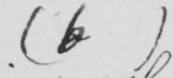Please transcribe the handwritten text in this image. ( b ) 